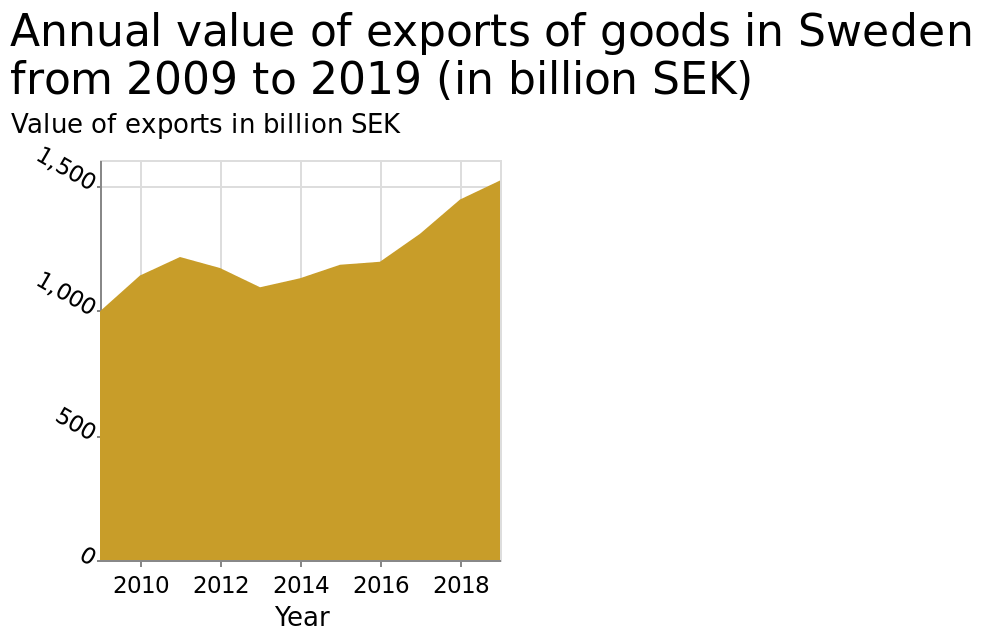<image>
Can we expect the value of export goods to continue increasing in the future?  The information provided does not give any indication about the future trend of the value of export goods. 